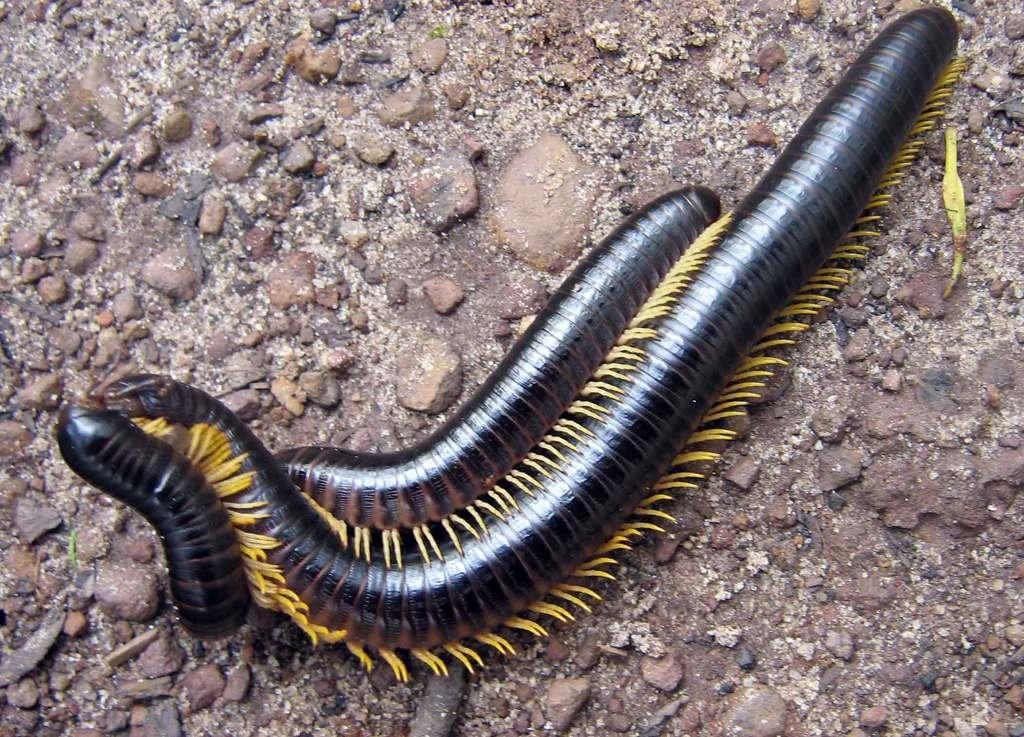What creatures are present in the image? There are two leeches in the image. Where are the leeches located in the image? The leeches are in the center of the image. What type of cactus can be seen in the image? There is no cactus present in the image; it features two leeches. What type of wine is being served in the image? There is no wine present in the image. 